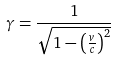Convert formula to latex. <formula><loc_0><loc_0><loc_500><loc_500>\gamma = \frac { 1 } { \sqrt { 1 - \left ( \frac { v } { c } \right ) ^ { 2 } } }</formula> 